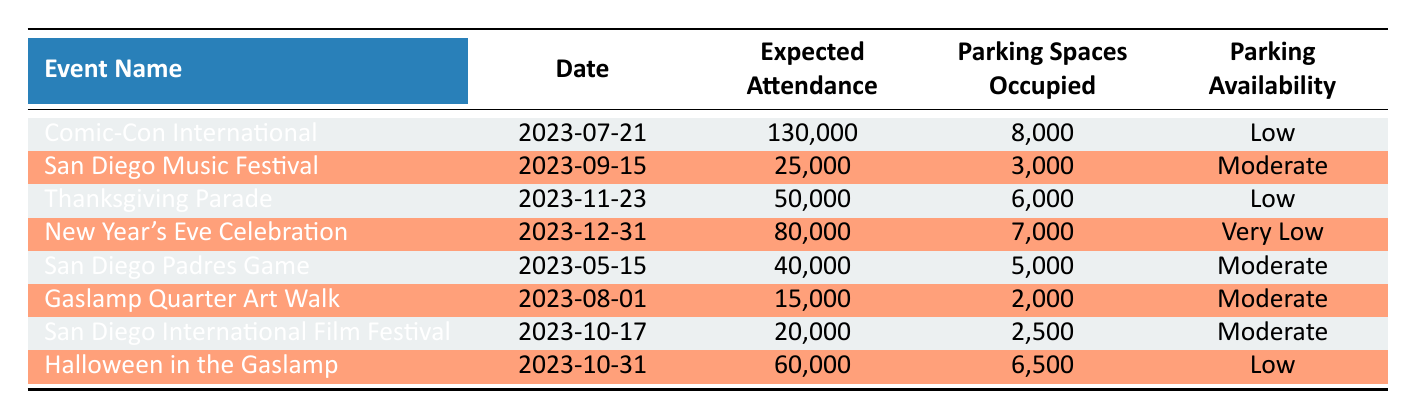What is the expected attendance for the Comic-Con International event? The table lists the expected attendance for each event. For Comic-Con International, the expected attendance is clearly stated as 130,000.
Answer: 130,000 How many parking spaces were occupied during the San Diego Music Festival? From the table, we can see that the San Diego Music Festival occupied a total of 3,000 parking spaces.
Answer: 3,000 What is the parking availability for the New Year's Eve Celebration? Referring to the table, the parking availability for the New Year's Eve Celebration is indicated as "Very Low."
Answer: Very Low How many more parking spaces were occupied during Comic-Con International compared to the Halloween in the Gaslamp event? Comic-Con International occupied 8,000 parking spaces, while Halloween in the Gaslamp occupied 6,500. The difference is 8,000 - 6,500 = 1,500 parking spaces.
Answer: 1,500 What is the average expected attendance of all events listed? To find the average expected attendance, we sum the expected attendance of all events: 130,000 + 25,000 + 50,000 + 80,000 + 40,000 + 15,000 + 20,000 + 60,000 = 410,000. There are 8 events, so the average is 410,000 / 8 = 51,250.
Answer: 51,250 Is the parking availability for the Thanksgiving Parade low? The parking availability for the Thanksgiving Parade is listed as "Low" in the table. Therefore, the statement is true.
Answer: Yes Are there any events with "Moderate" parking availability which attended more than 20,000 people? The events with "Moderate" parking availability that also had expected attendance over 20,000 are: San Diego Padres Game (40,000) and San Diego International Film Festival (20,000). This confirms that there are two such events.
Answer: Yes How many total parking spaces were occupied during the events that have low parking availability? The events with low parking availability are Comic-Con International (8,000), Thanksgiving Parade (6,000), and Halloween in the Gaslamp (6,500). The total occupied parking spaces is 8,000 + 6,000 + 6,500 = 20,500.
Answer: 20,500 Which event had the lowest expected attendance? Looking at the expected attendance figures, the Gaslamp Quarter Art Walk has the lowest expected attendance of 15,000 when compared to other events.
Answer: 15,000 